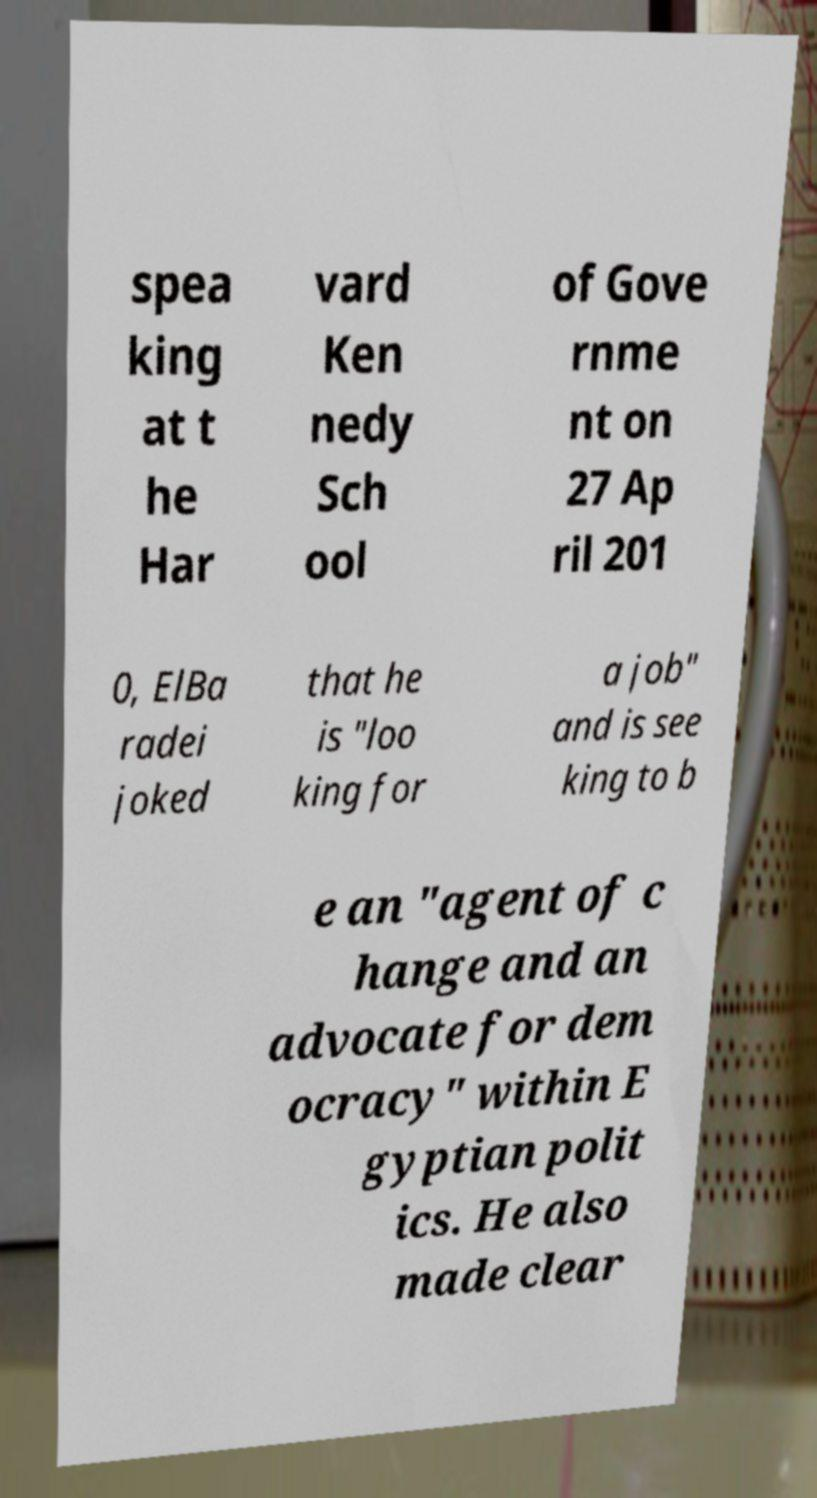For documentation purposes, I need the text within this image transcribed. Could you provide that? spea king at t he Har vard Ken nedy Sch ool of Gove rnme nt on 27 Ap ril 201 0, ElBa radei joked that he is "loo king for a job" and is see king to b e an "agent of c hange and an advocate for dem ocracy" within E gyptian polit ics. He also made clear 